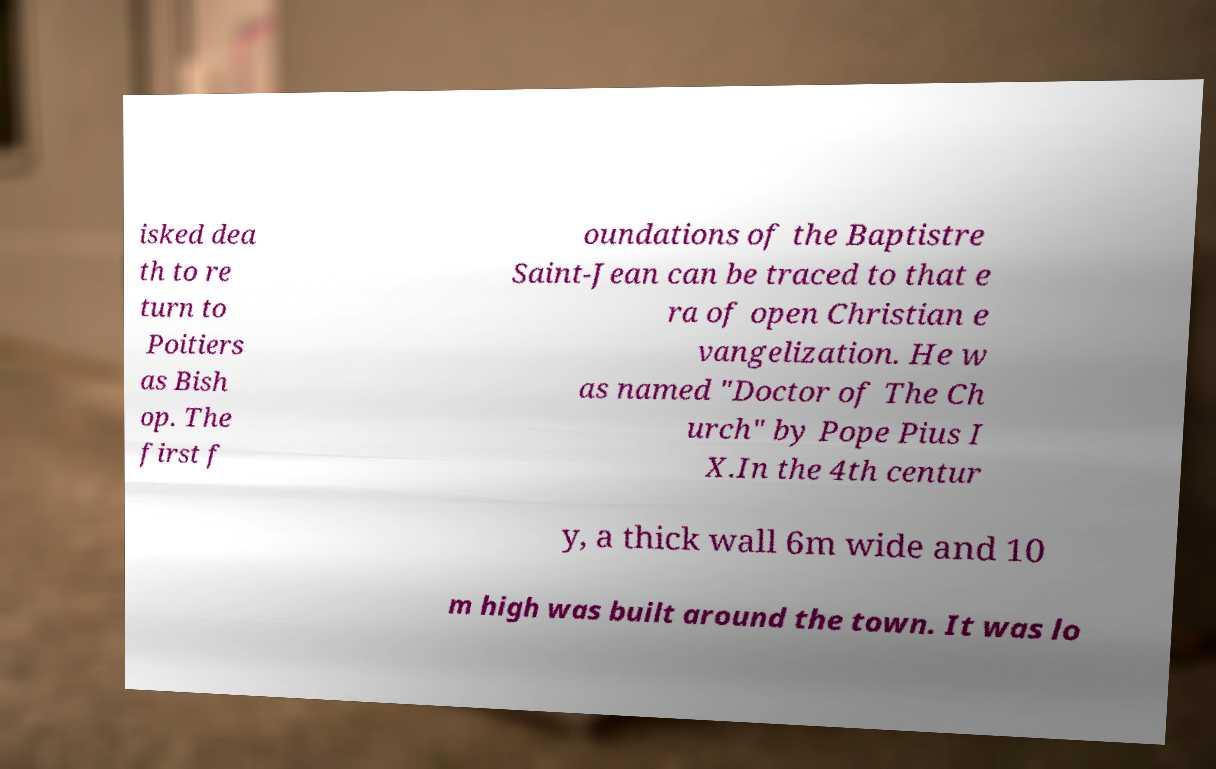Can you accurately transcribe the text from the provided image for me? isked dea th to re turn to Poitiers as Bish op. The first f oundations of the Baptistre Saint-Jean can be traced to that e ra of open Christian e vangelization. He w as named "Doctor of The Ch urch" by Pope Pius I X.In the 4th centur y, a thick wall 6m wide and 10 m high was built around the town. It was lo 